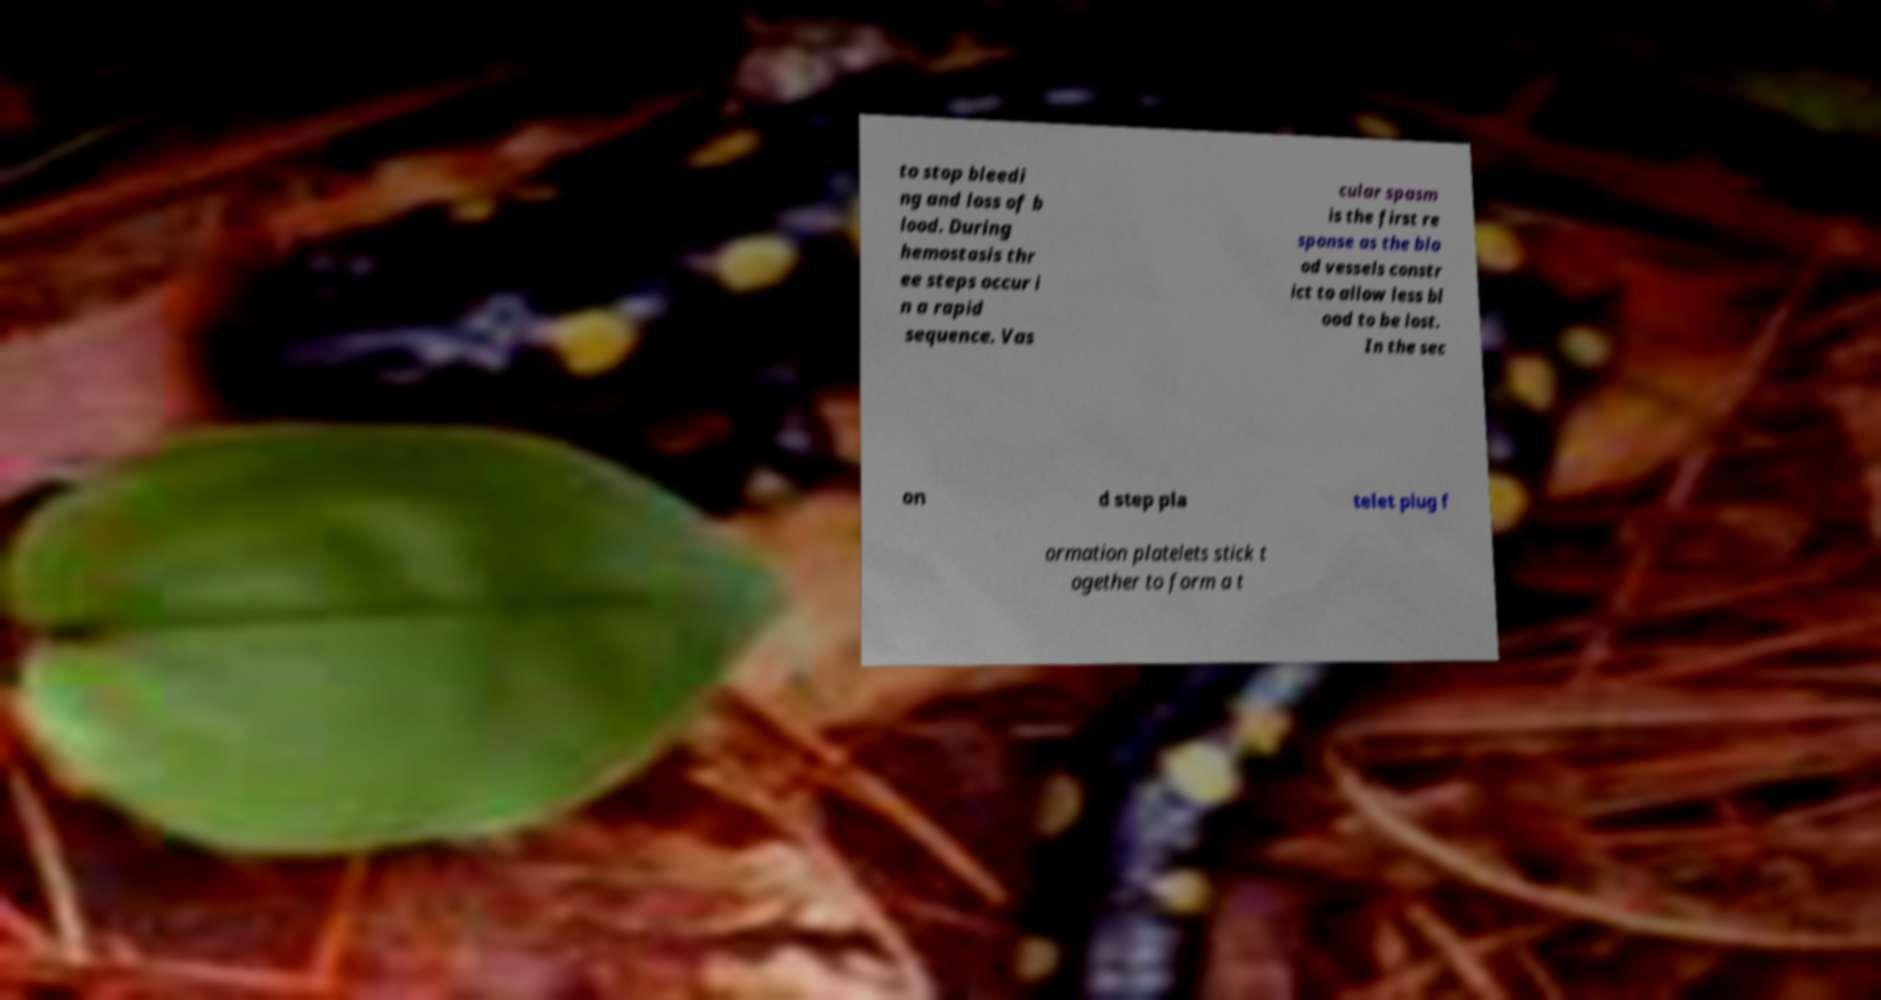Please identify and transcribe the text found in this image. to stop bleedi ng and loss of b lood. During hemostasis thr ee steps occur i n a rapid sequence. Vas cular spasm is the first re sponse as the blo od vessels constr ict to allow less bl ood to be lost. In the sec on d step pla telet plug f ormation platelets stick t ogether to form a t 